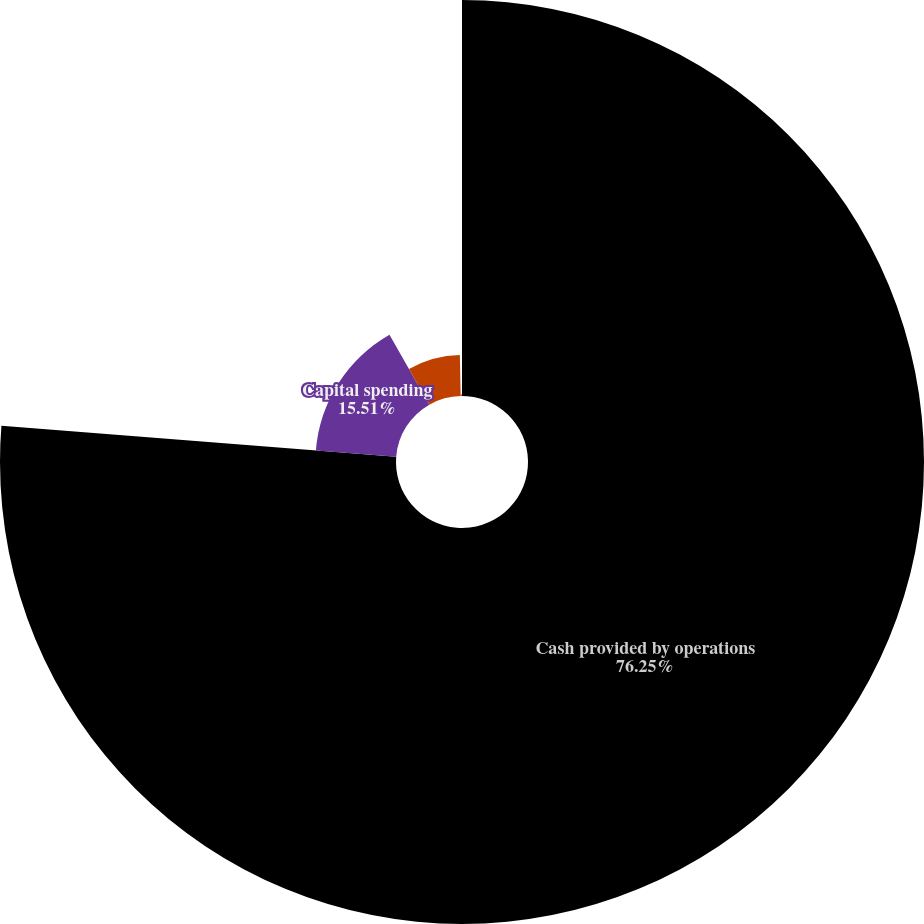<chart> <loc_0><loc_0><loc_500><loc_500><pie_chart><fcel>Cash provided by operations<fcel>Capital spending<fcel>Ratio of total debt and<fcel>Pretax interest coverage-times<nl><fcel>76.25%<fcel>15.51%<fcel>7.92%<fcel>0.32%<nl></chart> 